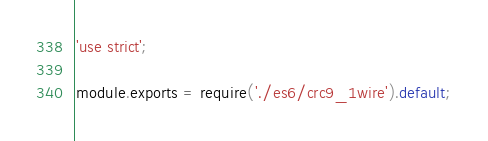Convert code to text. <code><loc_0><loc_0><loc_500><loc_500><_JavaScript_>'use strict';

module.exports = require('./es6/crc9_1wire').default;
</code> 